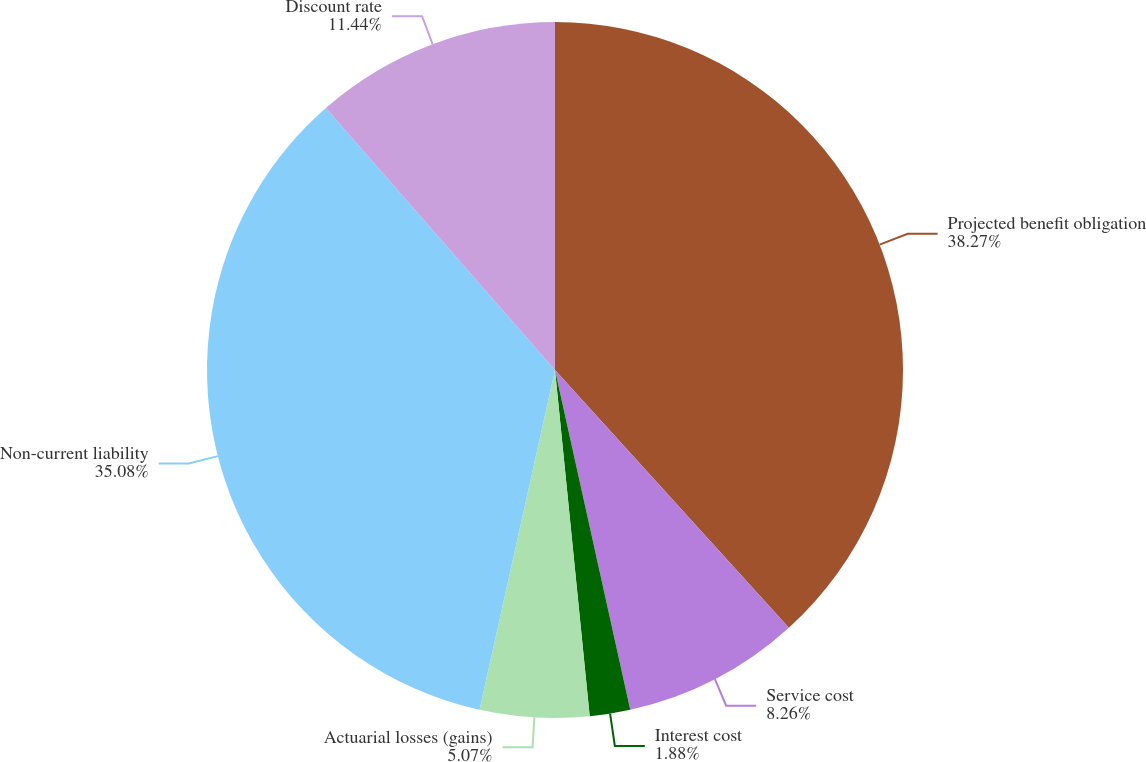Convert chart. <chart><loc_0><loc_0><loc_500><loc_500><pie_chart><fcel>Projected benefit obligation<fcel>Service cost<fcel>Interest cost<fcel>Actuarial losses (gains)<fcel>Non-current liability<fcel>Discount rate<nl><fcel>38.27%<fcel>8.26%<fcel>1.88%<fcel>5.07%<fcel>35.08%<fcel>11.44%<nl></chart> 